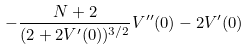Convert formula to latex. <formula><loc_0><loc_0><loc_500><loc_500>- \frac { N + 2 } { ( 2 + 2 V ^ { \prime } ( 0 ) ) ^ { 3 / 2 } } V ^ { \prime \prime } ( 0 ) - 2 V ^ { \prime } ( 0 )</formula> 